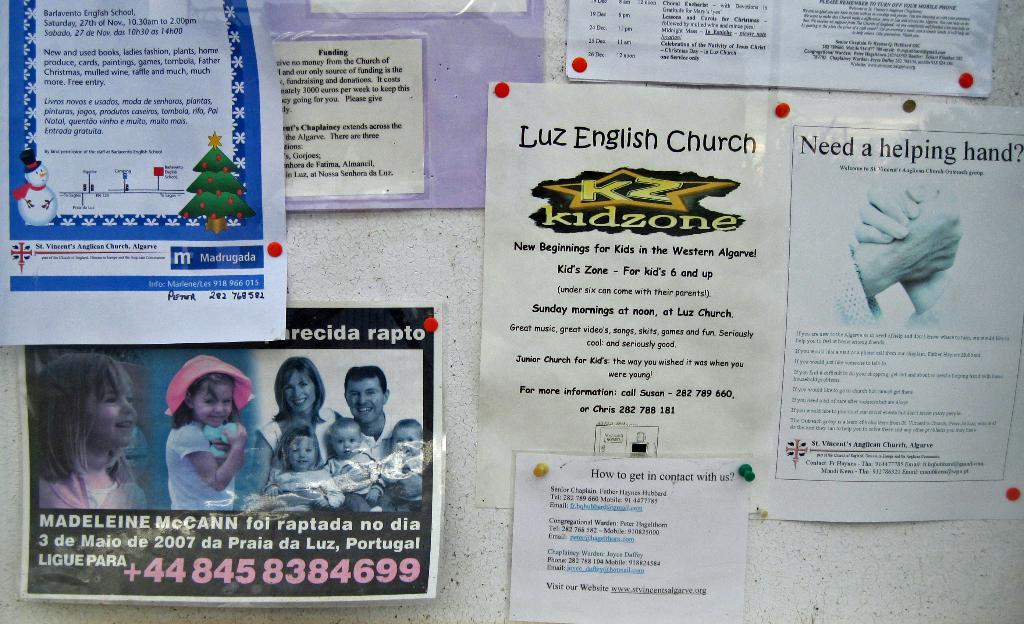What type of objects are featured in the image? There are stick bills in the image. How do the stick bills differ from one another? The stick bills have various fonts and images. What can be found on the stick bills? There is written text on the stick bills. What is visible in the background of the image? There is a wall in the background of the image. How many crooks can be seen coiling around the stick bills in the image? There are no crooks present in the image. 